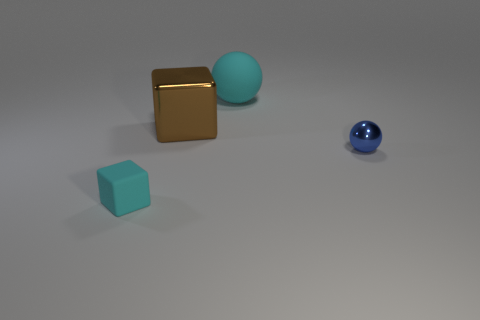Is the number of shiny balls greater than the number of spheres?
Offer a terse response. No. Is there any other thing that has the same color as the metal block?
Your answer should be compact. No. How many other things are there of the same size as the blue shiny sphere?
Give a very brief answer. 1. What material is the ball that is in front of the large metal block behind the ball in front of the large block?
Offer a very short reply. Metal. Do the brown block and the cyan object behind the tiny blue thing have the same material?
Give a very brief answer. No. Are there fewer shiny balls in front of the small cyan object than cyan blocks in front of the small blue metallic thing?
Provide a short and direct response. Yes. What number of small blue things are made of the same material as the big cube?
Provide a succinct answer. 1. Is there a small blue sphere that is in front of the big matte thing that is behind the cube in front of the shiny sphere?
Offer a very short reply. Yes. How many cylinders are large red metallic things or cyan matte things?
Keep it short and to the point. 0. There is a brown thing; is its shape the same as the cyan object behind the blue ball?
Ensure brevity in your answer.  No. 